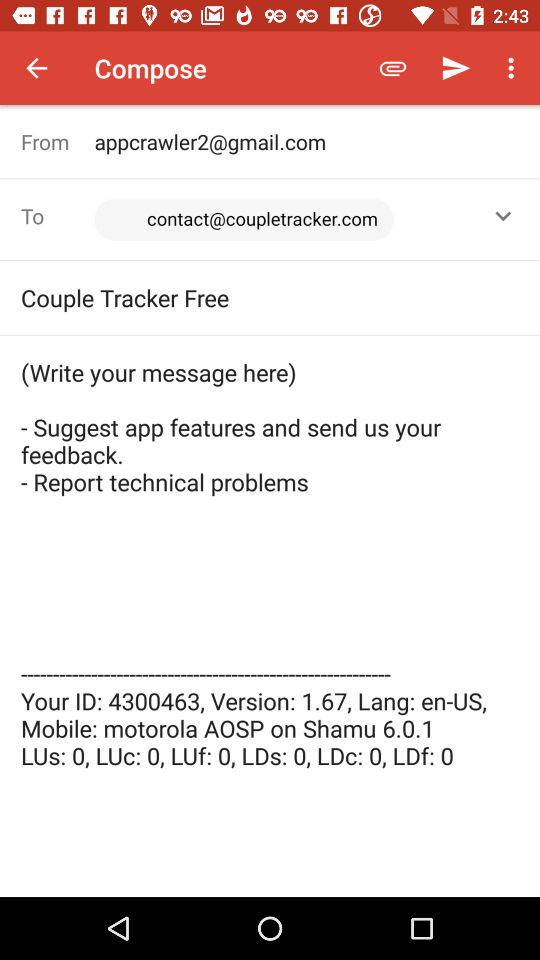What is the language? The language is en-US. 